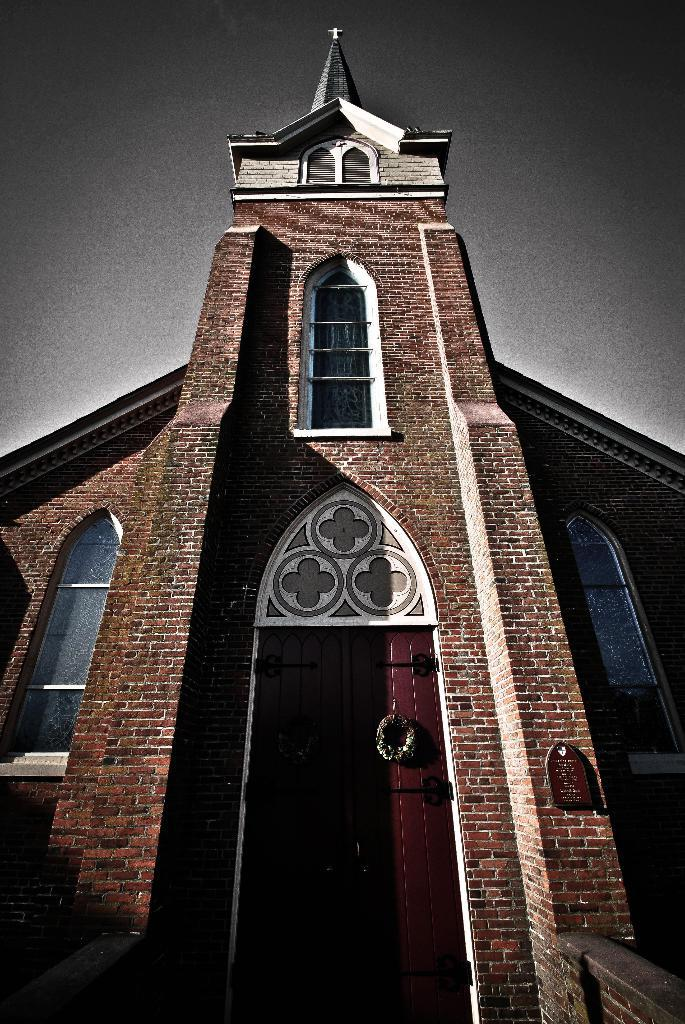What type of structure is present in the image? There is a building in the image. What features can be observed on the building? The building has windows and doors. Is there any signage or noticeable objects on the building? Yes, there is a board on the wall of the building. What symbol is present on the building? The building has a cross symbol. What can be seen in the background of the image? The sky is visible in the image. Can you tell me how many people are swimming in the lake in the image? There is no lake or people swimming present in the image; it features a building with a cross symbol. What type of pocket is visible on the building in the image? There is no pocket present on the building in the image. 